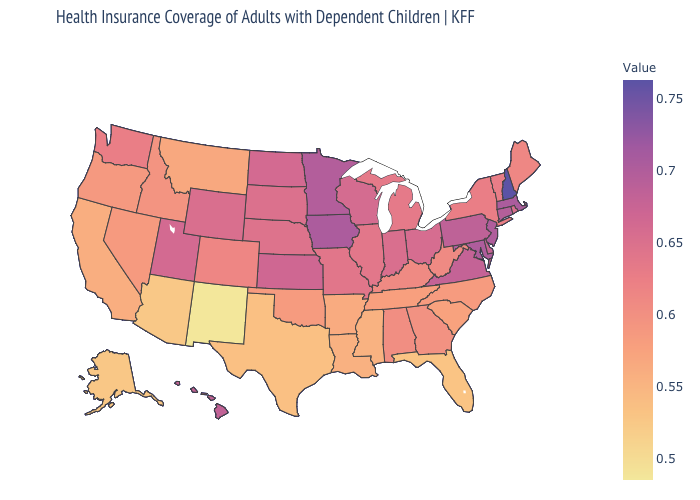Which states have the lowest value in the MidWest?
Quick response, please. Michigan. Does Oklahoma have a higher value than Arizona?
Concise answer only. Yes. Does Georgia have a lower value than New Mexico?
Quick response, please. No. Does the map have missing data?
Short answer required. No. Among the states that border Idaho , which have the highest value?
Concise answer only. Utah. Does Nebraska have the highest value in the USA?
Quick response, please. No. Among the states that border North Dakota , which have the lowest value?
Be succinct. Montana. 